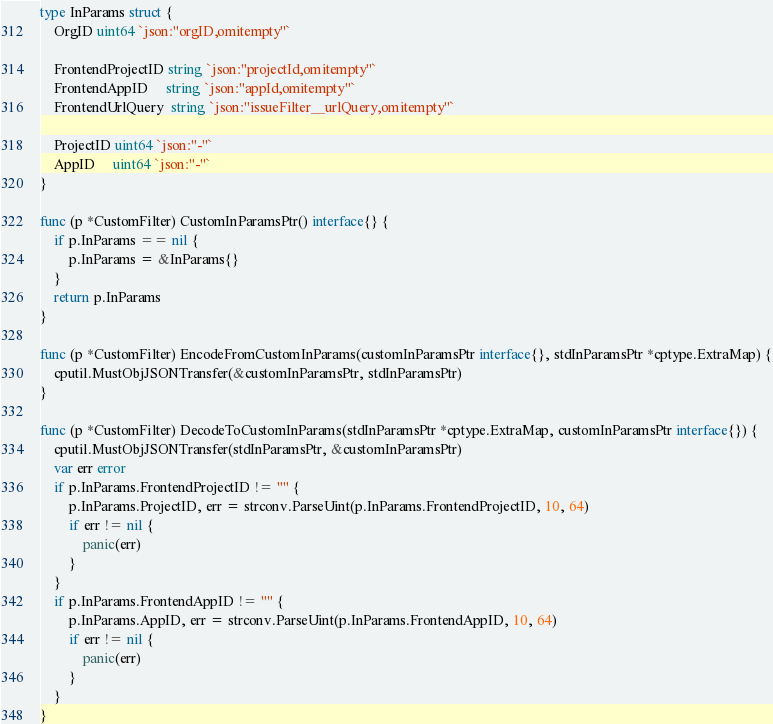Convert code to text. <code><loc_0><loc_0><loc_500><loc_500><_Go_>
type InParams struct {
	OrgID uint64 `json:"orgID,omitempty"`

	FrontendProjectID string `json:"projectId,omitempty"`
	FrontendAppID     string `json:"appId,omitempty"`
	FrontendUrlQuery  string `json:"issueFilter__urlQuery,omitempty"`

	ProjectID uint64 `json:"-"`
	AppID     uint64 `json:"-"`
}

func (p *CustomFilter) CustomInParamsPtr() interface{} {
	if p.InParams == nil {
		p.InParams = &InParams{}
	}
	return p.InParams
}

func (p *CustomFilter) EncodeFromCustomInParams(customInParamsPtr interface{}, stdInParamsPtr *cptype.ExtraMap) {
	cputil.MustObjJSONTransfer(&customInParamsPtr, stdInParamsPtr)
}

func (p *CustomFilter) DecodeToCustomInParams(stdInParamsPtr *cptype.ExtraMap, customInParamsPtr interface{}) {
	cputil.MustObjJSONTransfer(stdInParamsPtr, &customInParamsPtr)
	var err error
	if p.InParams.FrontendProjectID != "" {
		p.InParams.ProjectID, err = strconv.ParseUint(p.InParams.FrontendProjectID, 10, 64)
		if err != nil {
			panic(err)
		}
	}
	if p.InParams.FrontendAppID != "" {
		p.InParams.AppID, err = strconv.ParseUint(p.InParams.FrontendAppID, 10, 64)
		if err != nil {
			panic(err)
		}
	}
}
</code> 